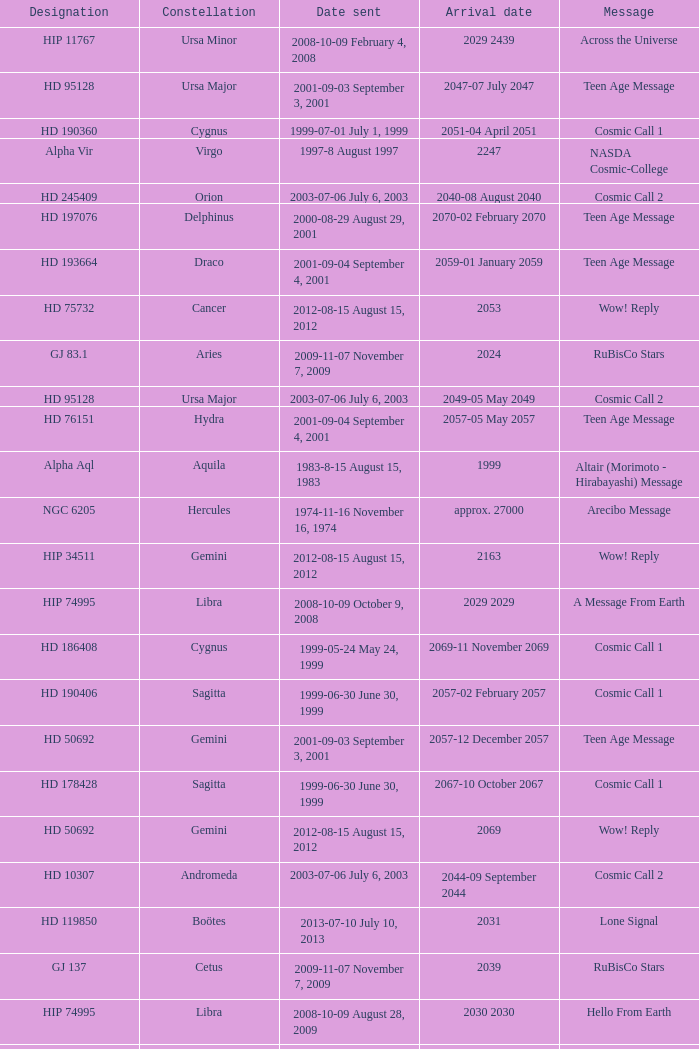Where is Hip 4872? Cassiopeia. 